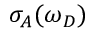Convert formula to latex. <formula><loc_0><loc_0><loc_500><loc_500>\sigma _ { A } ( \omega _ { D } )</formula> 